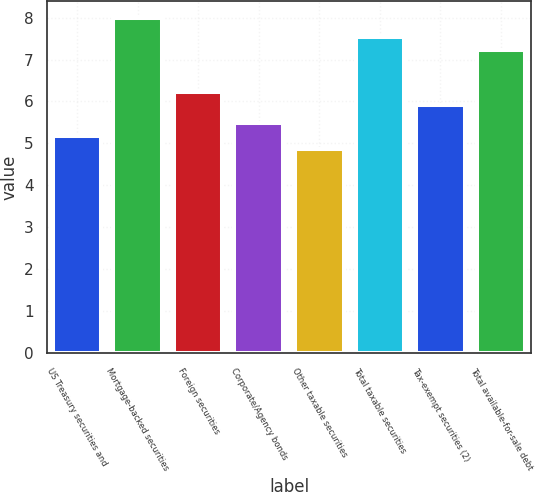Convert chart to OTSL. <chart><loc_0><loc_0><loc_500><loc_500><bar_chart><fcel>US Treasury securities and<fcel>Mortgage-backed securities<fcel>Foreign securities<fcel>Corporate/Agency bonds<fcel>Other taxable securities<fcel>Total taxable securities<fcel>Tax-exempt securities (2)<fcel>Total available-for-sale debt<nl><fcel>5.18<fcel>7.99<fcel>6.22<fcel>5.49<fcel>4.87<fcel>7.53<fcel>5.91<fcel>7.22<nl></chart> 